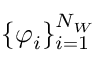<formula> <loc_0><loc_0><loc_500><loc_500>\{ \varphi _ { i } \} _ { i = 1 } ^ { N _ { W } }</formula> 